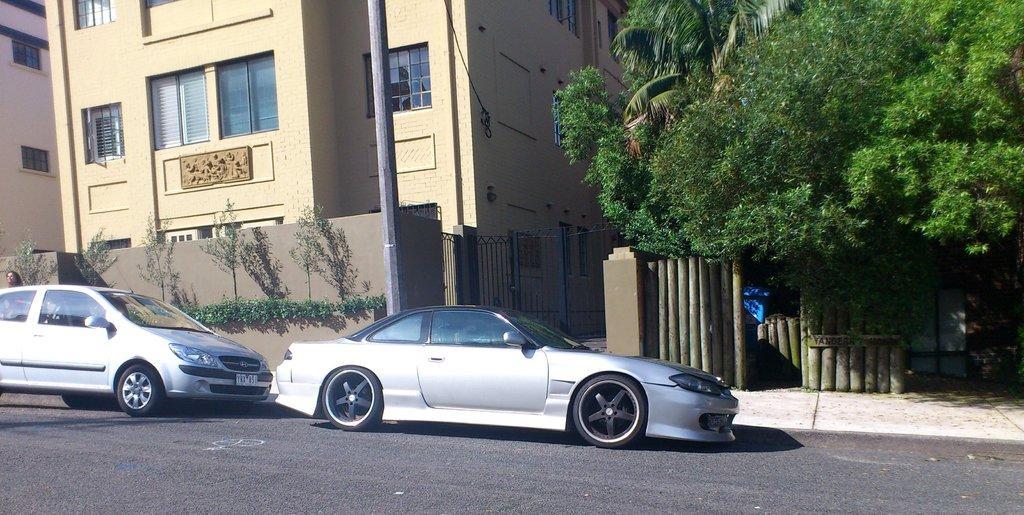Could you give a brief overview of what you see in this image? In this image there are cars on the road. In the background there are buildings, trees and in front of the building there are plants and there is a pole. 